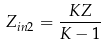Convert formula to latex. <formula><loc_0><loc_0><loc_500><loc_500>Z _ { i n 2 } = \frac { K Z } { K - 1 }</formula> 